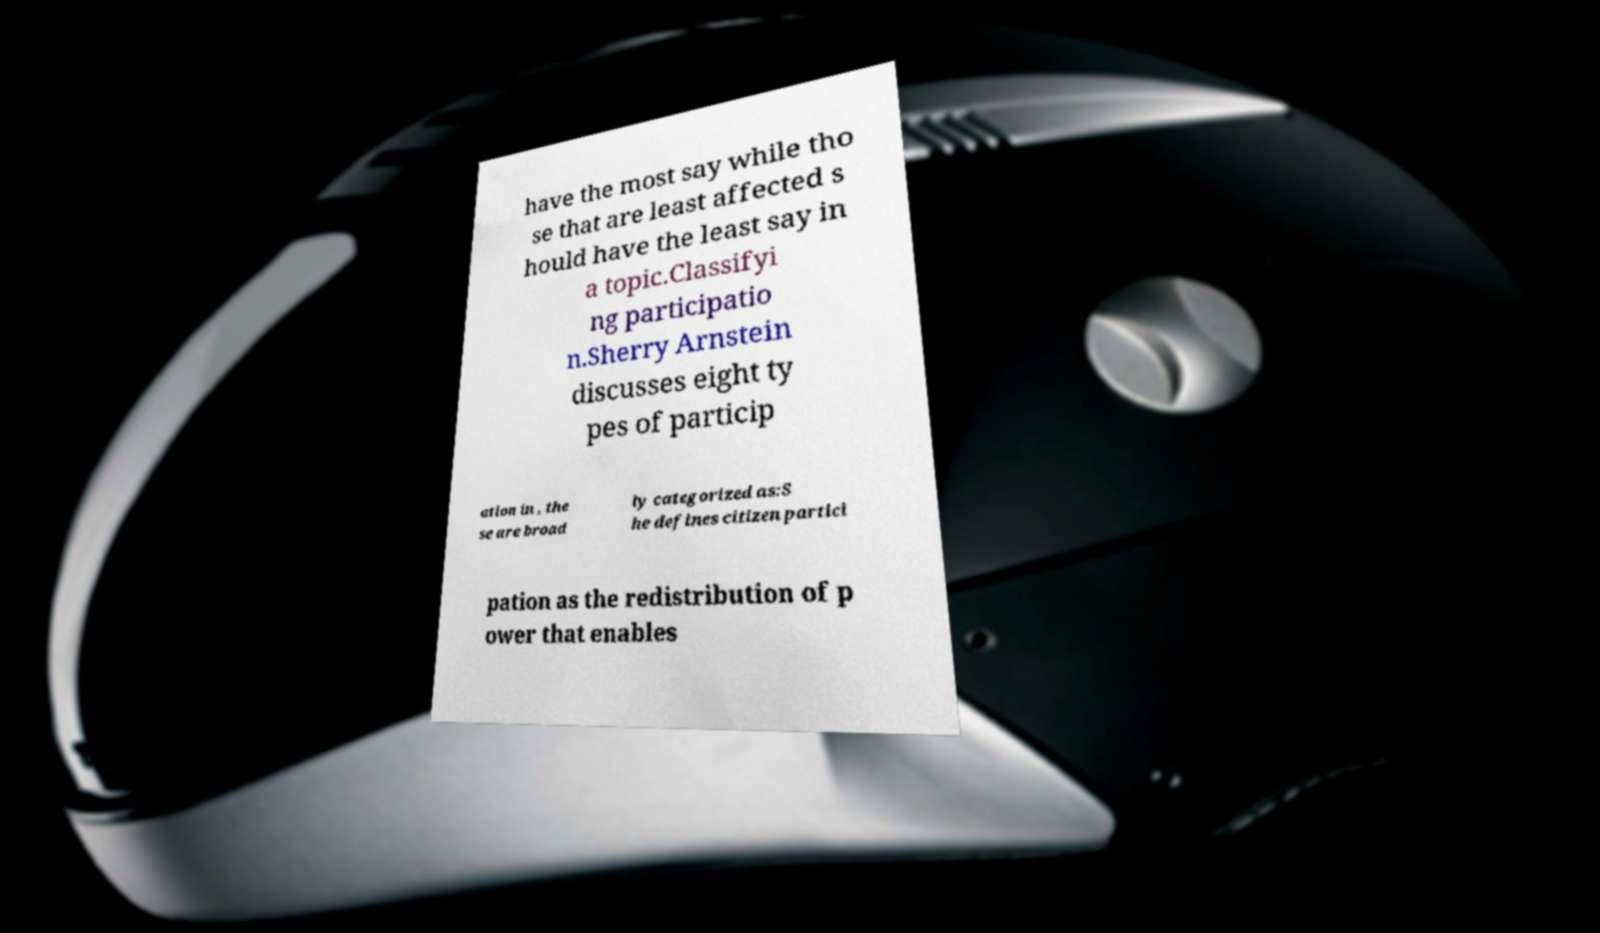Can you accurately transcribe the text from the provided image for me? have the most say while tho se that are least affected s hould have the least say in a topic.Classifyi ng participatio n.Sherry Arnstein discusses eight ty pes of particip ation in , the se are broad ly categorized as:S he defines citizen partici pation as the redistribution of p ower that enables 